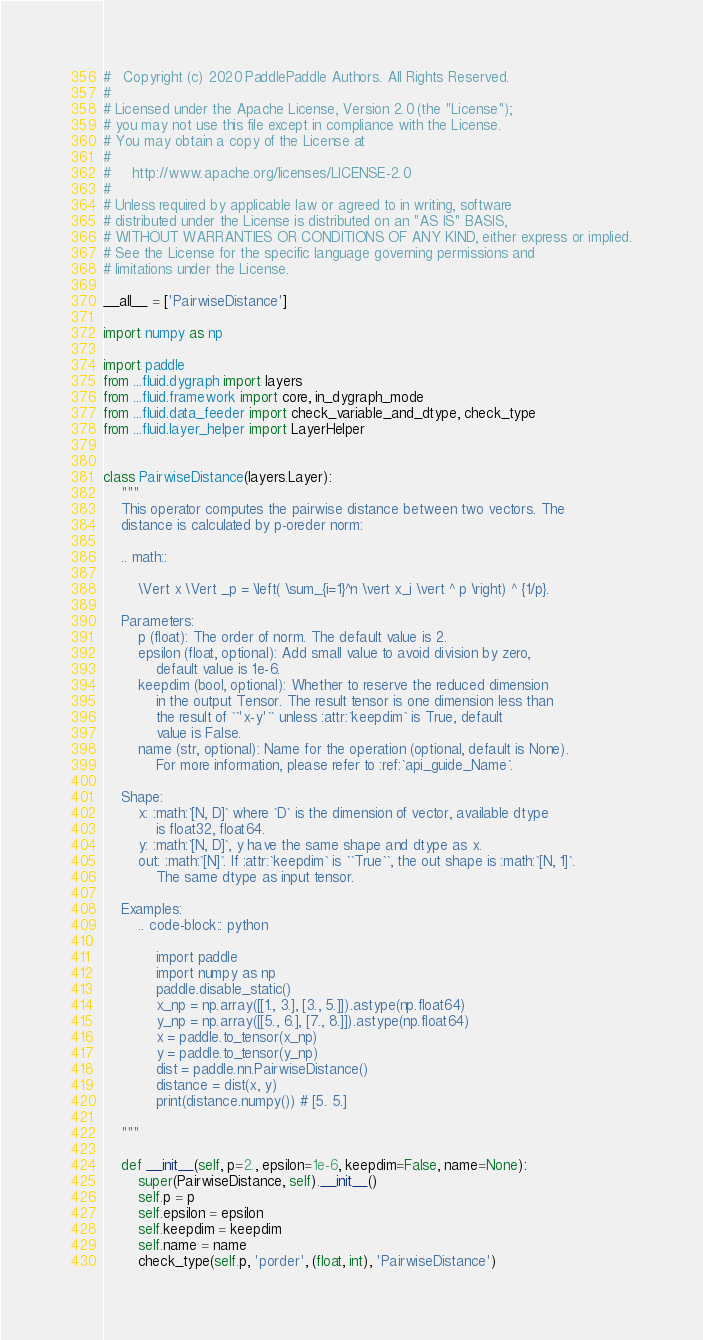Convert code to text. <code><loc_0><loc_0><loc_500><loc_500><_Python_>#   Copyright (c) 2020 PaddlePaddle Authors. All Rights Reserved.
#
# Licensed under the Apache License, Version 2.0 (the "License");
# you may not use this file except in compliance with the License.
# You may obtain a copy of the License at
#
#     http://www.apache.org/licenses/LICENSE-2.0
#
# Unless required by applicable law or agreed to in writing, software
# distributed under the License is distributed on an "AS IS" BASIS,
# WITHOUT WARRANTIES OR CONDITIONS OF ANY KIND, either express or implied.
# See the License for the specific language governing permissions and
# limitations under the License.

__all__ = ['PairwiseDistance']

import numpy as np

import paddle
from ...fluid.dygraph import layers
from ...fluid.framework import core, in_dygraph_mode
from ...fluid.data_feeder import check_variable_and_dtype, check_type
from ...fluid.layer_helper import LayerHelper


class PairwiseDistance(layers.Layer):
    """
    This operator computes the pairwise distance between two vectors. The
    distance is calculated by p-oreder norm:

    .. math::

        \Vert x \Vert _p = \left( \sum_{i=1}^n \vert x_i \vert ^ p \right) ^ {1/p}.

    Parameters:
        p (float): The order of norm. The default value is 2.
        epsilon (float, optional): Add small value to avoid division by zero,
            default value is 1e-6.
        keepdim (bool, optional): Whether to reserve the reduced dimension
            in the output Tensor. The result tensor is one dimension less than
            the result of ``'x-y'`` unless :attr:`keepdim` is True, default
            value is False.
        name (str, optional): Name for the operation (optional, default is None).
            For more information, please refer to :ref:`api_guide_Name`.

    Shape:
        x: :math:`[N, D]` where `D` is the dimension of vector, available dtype
            is float32, float64.
        y: :math:`[N, D]`, y have the same shape and dtype as x.
        out: :math:`[N]`. If :attr:`keepdim` is ``True``, the out shape is :math:`[N, 1]`.
            The same dtype as input tensor.

    Examples:
        .. code-block:: python

            import paddle
            import numpy as np
            paddle.disable_static()
            x_np = np.array([[1., 3.], [3., 5.]]).astype(np.float64)
            y_np = np.array([[5., 6.], [7., 8.]]).astype(np.float64)
            x = paddle.to_tensor(x_np)
            y = paddle.to_tensor(y_np)
            dist = paddle.nn.PairwiseDistance()
            distance = dist(x, y)
            print(distance.numpy()) # [5. 5.]

    """

    def __init__(self, p=2., epsilon=1e-6, keepdim=False, name=None):
        super(PairwiseDistance, self).__init__()
        self.p = p
        self.epsilon = epsilon
        self.keepdim = keepdim
        self.name = name
        check_type(self.p, 'porder', (float, int), 'PairwiseDistance')</code> 